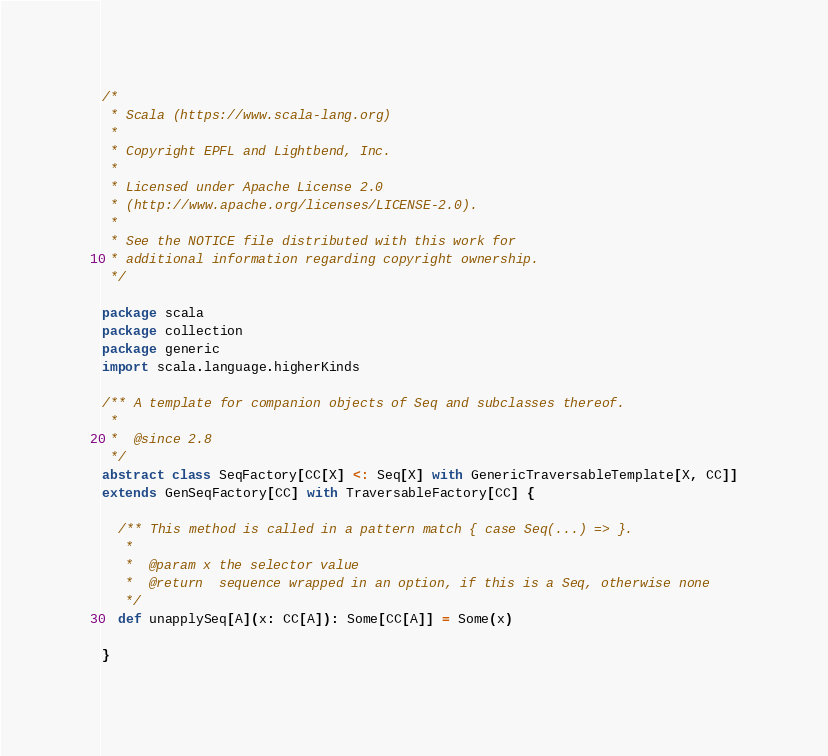<code> <loc_0><loc_0><loc_500><loc_500><_Scala_>/*
 * Scala (https://www.scala-lang.org)
 *
 * Copyright EPFL and Lightbend, Inc.
 *
 * Licensed under Apache License 2.0
 * (http://www.apache.org/licenses/LICENSE-2.0).
 *
 * See the NOTICE file distributed with this work for
 * additional information regarding copyright ownership.
 */

package scala
package collection
package generic
import scala.language.higherKinds

/** A template for companion objects of Seq and subclasses thereof.
 *
 *  @since 2.8
 */
abstract class SeqFactory[CC[X] <: Seq[X] with GenericTraversableTemplate[X, CC]]
extends GenSeqFactory[CC] with TraversableFactory[CC] {

  /** This method is called in a pattern match { case Seq(...) => }.
   *
   *  @param x the selector value
   *  @return  sequence wrapped in an option, if this is a Seq, otherwise none
   */
  def unapplySeq[A](x: CC[A]): Some[CC[A]] = Some(x)

}

</code> 